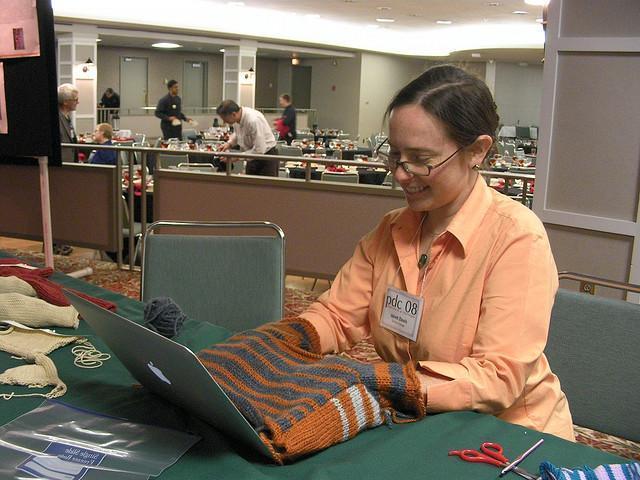How many people are there?
Give a very brief answer. 2. How many chairs are there?
Give a very brief answer. 2. 